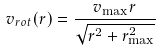Convert formula to latex. <formula><loc_0><loc_0><loc_500><loc_500>v _ { r o t } ( r ) = \frac { v _ { \max } r } { \sqrt { r ^ { 2 } + r _ { \max } ^ { 2 } } }</formula> 